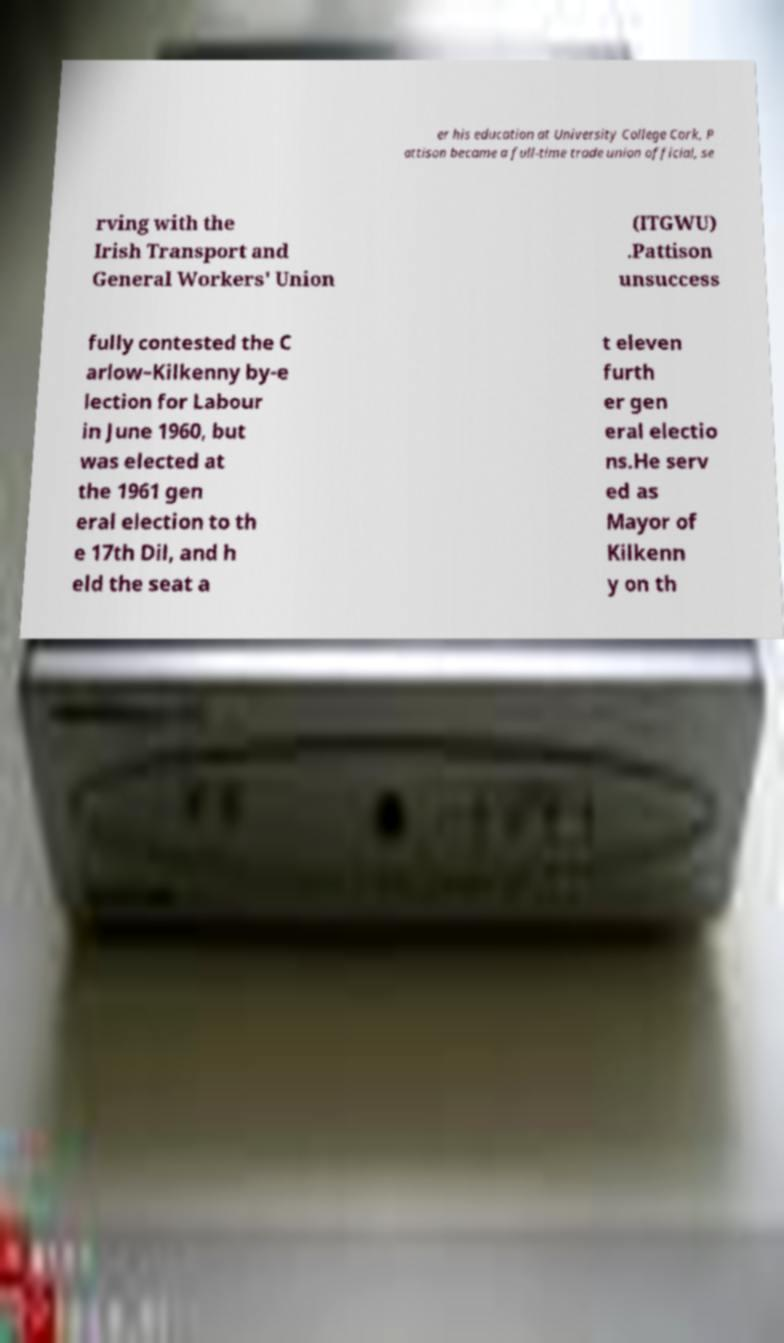For documentation purposes, I need the text within this image transcribed. Could you provide that? er his education at University College Cork, P attison became a full-time trade union official, se rving with the Irish Transport and General Workers' Union (ITGWU) .Pattison unsuccess fully contested the C arlow–Kilkenny by-e lection for Labour in June 1960, but was elected at the 1961 gen eral election to th e 17th Dil, and h eld the seat a t eleven furth er gen eral electio ns.He serv ed as Mayor of Kilkenn y on th 